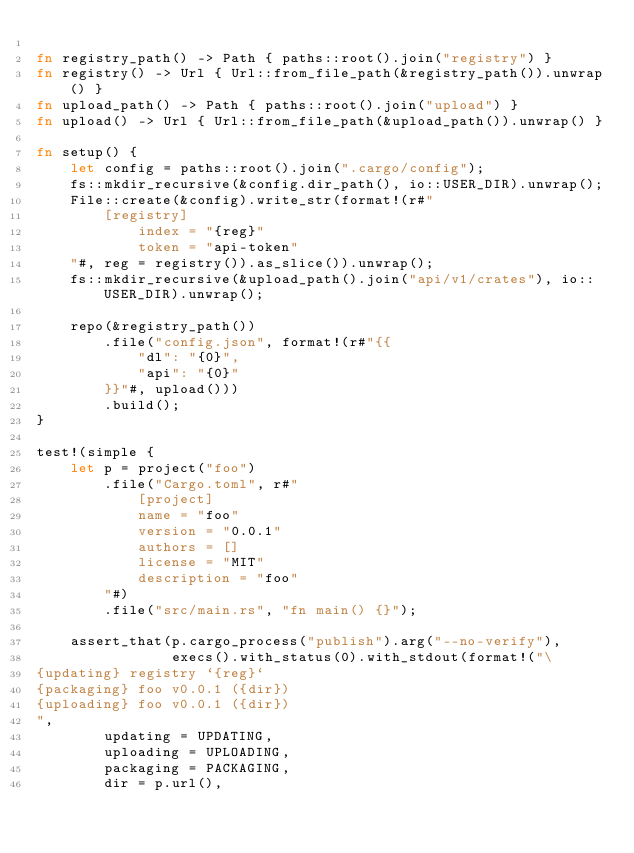<code> <loc_0><loc_0><loc_500><loc_500><_Rust_>
fn registry_path() -> Path { paths::root().join("registry") }
fn registry() -> Url { Url::from_file_path(&registry_path()).unwrap() }
fn upload_path() -> Path { paths::root().join("upload") }
fn upload() -> Url { Url::from_file_path(&upload_path()).unwrap() }

fn setup() {
    let config = paths::root().join(".cargo/config");
    fs::mkdir_recursive(&config.dir_path(), io::USER_DIR).unwrap();
    File::create(&config).write_str(format!(r#"
        [registry]
            index = "{reg}"
            token = "api-token"
    "#, reg = registry()).as_slice()).unwrap();
    fs::mkdir_recursive(&upload_path().join("api/v1/crates"), io::USER_DIR).unwrap();

    repo(&registry_path())
        .file("config.json", format!(r#"{{
            "dl": "{0}",
            "api": "{0}"
        }}"#, upload()))
        .build();
}

test!(simple {
    let p = project("foo")
        .file("Cargo.toml", r#"
            [project]
            name = "foo"
            version = "0.0.1"
            authors = []
            license = "MIT"
            description = "foo"
        "#)
        .file("src/main.rs", "fn main() {}");

    assert_that(p.cargo_process("publish").arg("--no-verify"),
                execs().with_status(0).with_stdout(format!("\
{updating} registry `{reg}`
{packaging} foo v0.0.1 ({dir})
{uploading} foo v0.0.1 ({dir})
",
        updating = UPDATING,
        uploading = UPLOADING,
        packaging = PACKAGING,
        dir = p.url(),</code> 